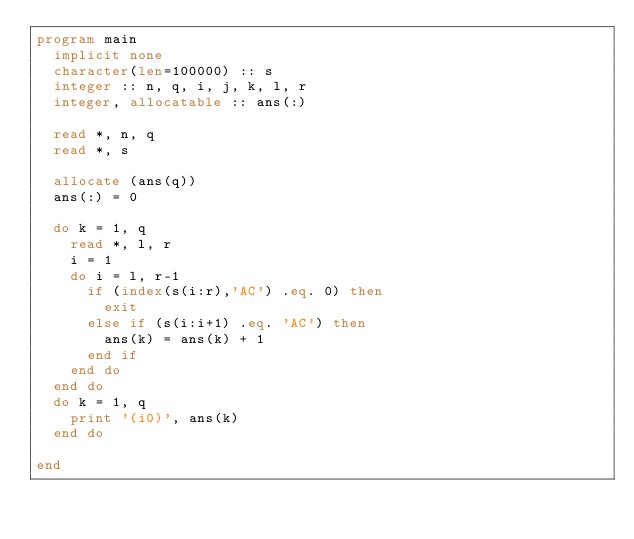Convert code to text. <code><loc_0><loc_0><loc_500><loc_500><_FORTRAN_>program main
  implicit none
  character(len=100000) :: s
  integer :: n, q, i, j, k, l, r
  integer, allocatable :: ans(:)

  read *, n, q
  read *, s

  allocate (ans(q))
  ans(:) = 0

  do k = 1, q
    read *, l, r
    i = 1
    do i = l, r-1
      if (index(s(i:r),'AC') .eq. 0) then
        exit
      else if (s(i:i+1) .eq. 'AC') then
        ans(k) = ans(k) + 1
      end if
    end do
  end do
  do k = 1, q
    print '(i0)', ans(k)
  end do

end</code> 